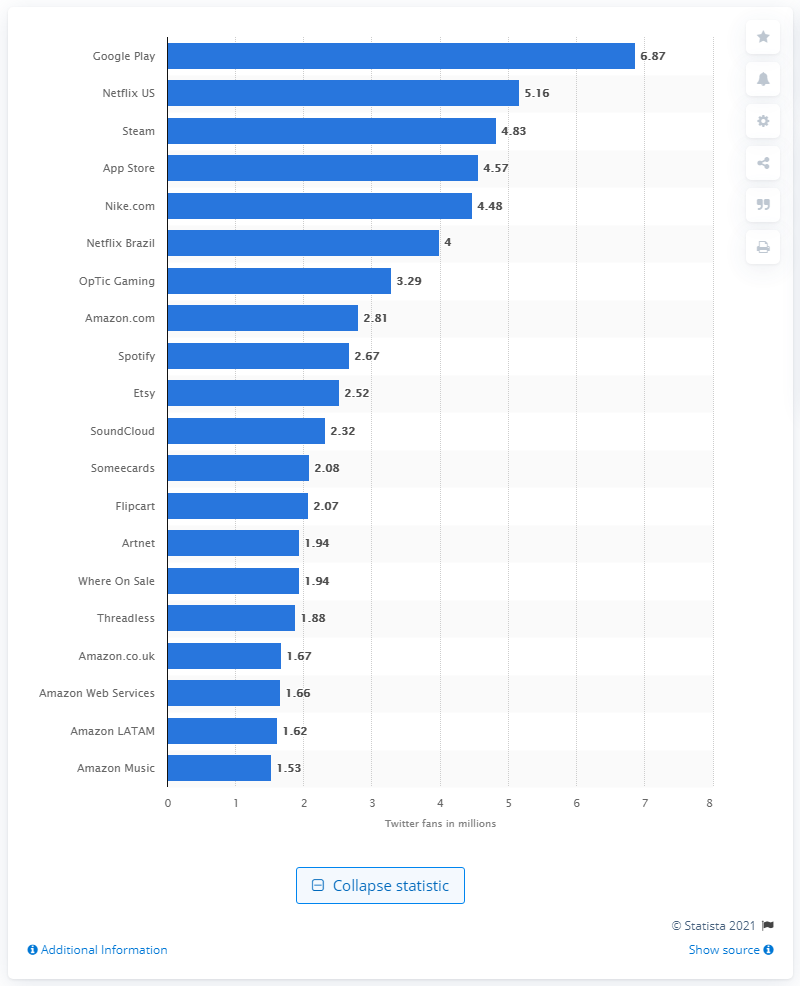Mention a couple of crucial points in this snapshot. As of July 2018, Apple had 4.57 million followers on Twitter. As of July 2018, Google Play had 6.87 million followers on Twitter. 